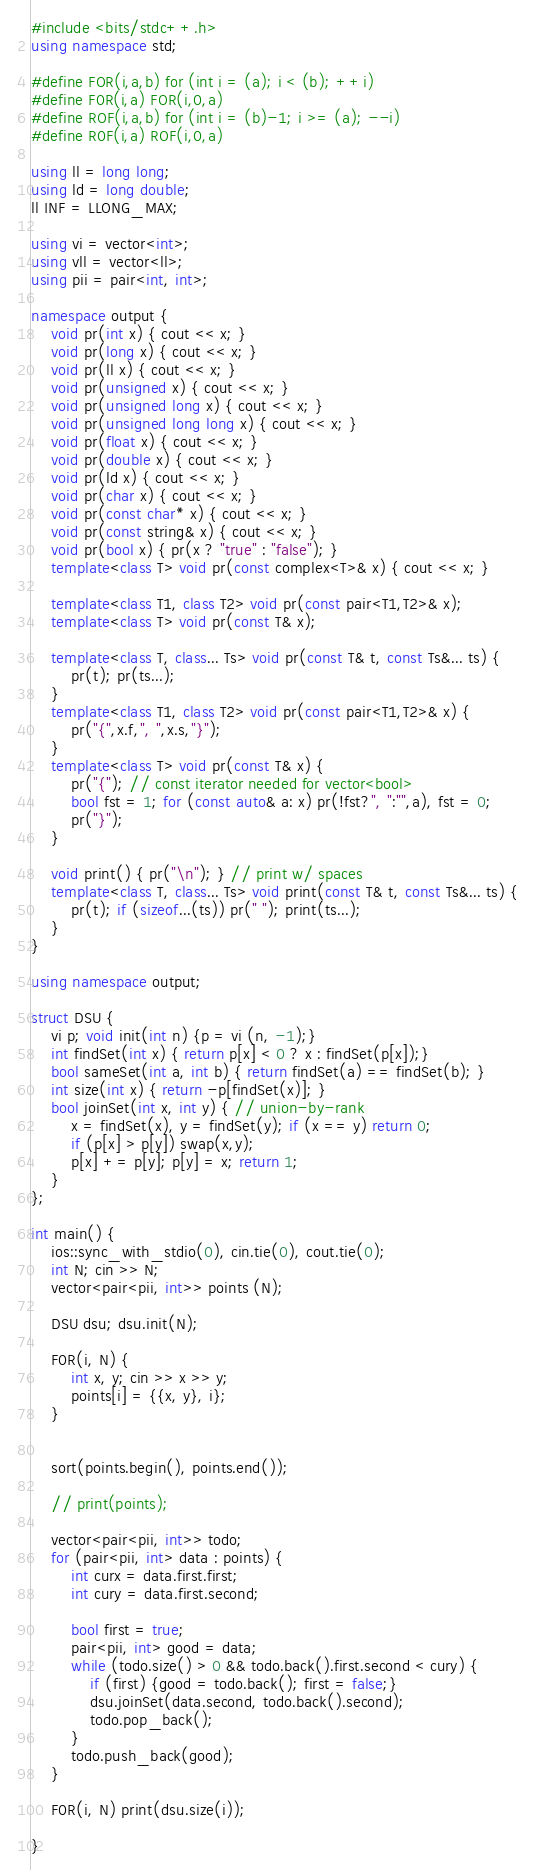<code> <loc_0><loc_0><loc_500><loc_500><_C++_>#include <bits/stdc++.h>
using namespace std;

#define FOR(i,a,b) for (int i = (a); i < (b); ++i)
#define F0R(i,a) FOR(i,0,a)
#define ROF(i,a,b) for (int i = (b)-1; i >= (a); --i)
#define R0F(i,a) ROF(i,0,a)

using ll = long long;
using ld = long double;
ll INF = LLONG_MAX;

using vi = vector<int>;
using vll = vector<ll>;
using pii = pair<int, int>;

namespace output {
	void pr(int x) { cout << x; }
	void pr(long x) { cout << x; }
	void pr(ll x) { cout << x; }
	void pr(unsigned x) { cout << x; }
	void pr(unsigned long x) { cout << x; }
	void pr(unsigned long long x) { cout << x; }
	void pr(float x) { cout << x; }
	void pr(double x) { cout << x; }
	void pr(ld x) { cout << x; }
	void pr(char x) { cout << x; }
	void pr(const char* x) { cout << x; }
	void pr(const string& x) { cout << x; }
	void pr(bool x) { pr(x ? "true" : "false"); }
	template<class T> void pr(const complex<T>& x) { cout << x; }
	
	template<class T1, class T2> void pr(const pair<T1,T2>& x);
	template<class T> void pr(const T& x);
	
	template<class T, class... Ts> void pr(const T& t, const Ts&... ts) { 
		pr(t); pr(ts...); 
	}
	template<class T1, class T2> void pr(const pair<T1,T2>& x) { 
		pr("{",x.f,", ",x.s,"}"); 
	}
	template<class T> void pr(const T& x) { 
		pr("{"); // const iterator needed for vector<bool>
		bool fst = 1; for (const auto& a: x) pr(!fst?", ":"",a), fst = 0; 
		pr("}");
	}
	
	void print() { pr("\n"); } // print w/ spaces
	template<class T, class... Ts> void print(const T& t, const Ts&... ts) { 
		pr(t); if (sizeof...(ts)) pr(" "); print(ts...); 
	}
}

using namespace output;

struct DSU {
    vi p; void init(int n) {p = vi (n, -1);}
    int findSet(int x) { return p[x] < 0 ? x : findSet(p[x]);}
    bool sameSet(int a, int b) { return findSet(a) == findSet(b); }
	int size(int x) { return -p[findSet(x)]; }
	bool joinSet(int x, int y) { // union-by-rank
		x = findSet(x), y = findSet(y); if (x == y) return 0;
		if (p[x] > p[y]) swap(x,y);
		p[x] += p[y]; p[y] = x; return 1;
	}
};

int main() {
    ios::sync_with_stdio(0), cin.tie(0), cout.tie(0);
	int N; cin >> N;
	vector<pair<pii, int>> points (N);

	DSU dsu; dsu.init(N);

	F0R(i, N) {
		int x, y; cin >> x >> y;
		points[i] = {{x, y}, i};
	}

	
	sort(points.begin(), points.end());
	
	// print(points);
	
	vector<pair<pii, int>> todo;
	for (pair<pii, int> data : points) {
		int curx = data.first.first;
		int cury = data.first.second;

		bool first = true;
		pair<pii, int> good = data;
		while (todo.size() > 0 && todo.back().first.second < cury) {
			if (first) {good = todo.back(); first = false;}
			dsu.joinSet(data.second, todo.back().second);
			todo.pop_back();
		}
		todo.push_back(good);
	}

	F0R(i, N) print(dsu.size(i));

}</code> 